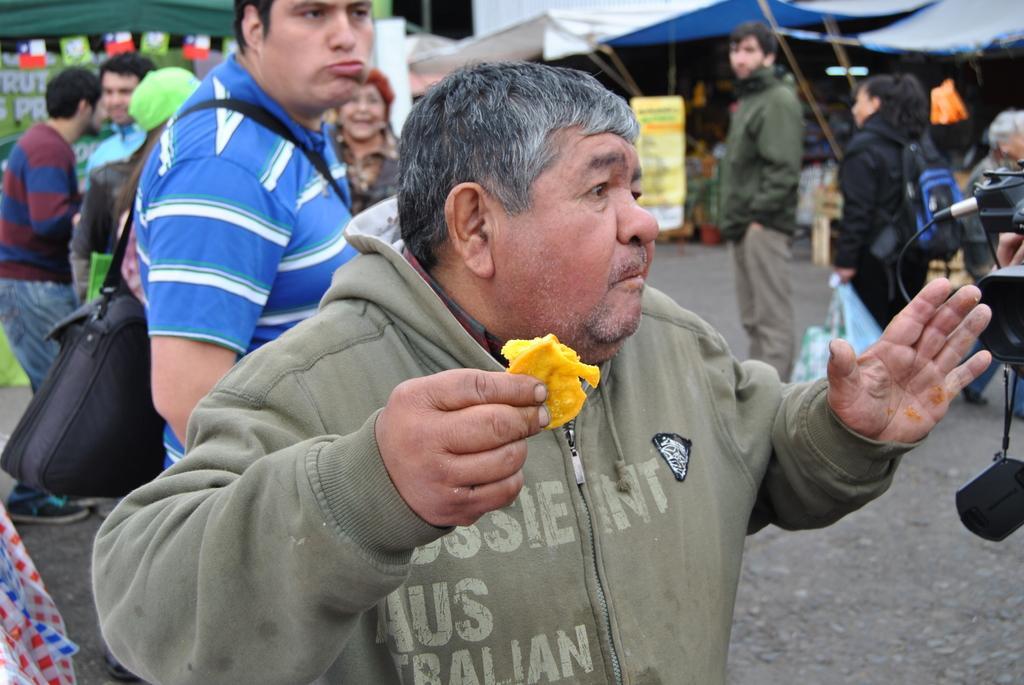How would you summarize this image in a sentence or two? In this picture we can see a group of people standing on the road, camera, banner and in the background we can see stalls. 